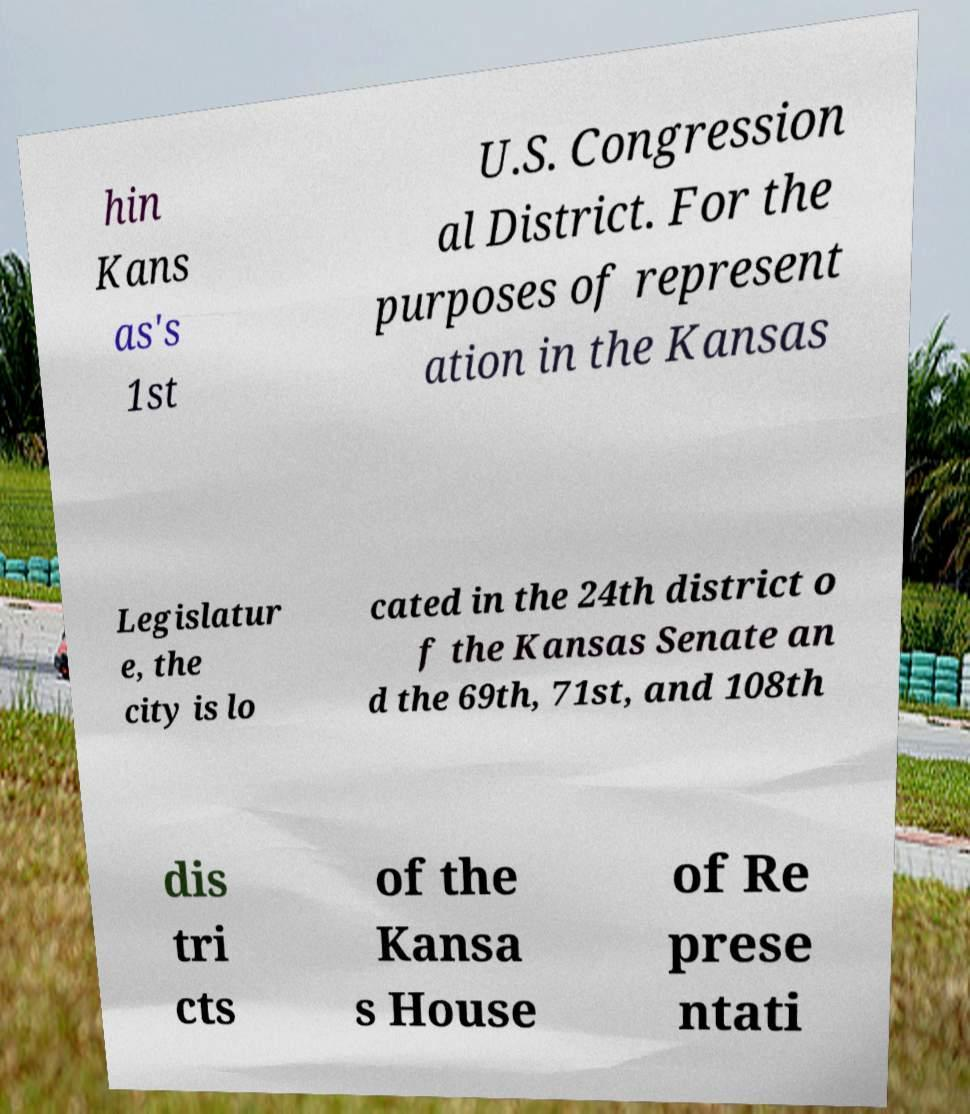Could you extract and type out the text from this image? hin Kans as's 1st U.S. Congression al District. For the purposes of represent ation in the Kansas Legislatur e, the city is lo cated in the 24th district o f the Kansas Senate an d the 69th, 71st, and 108th dis tri cts of the Kansa s House of Re prese ntati 